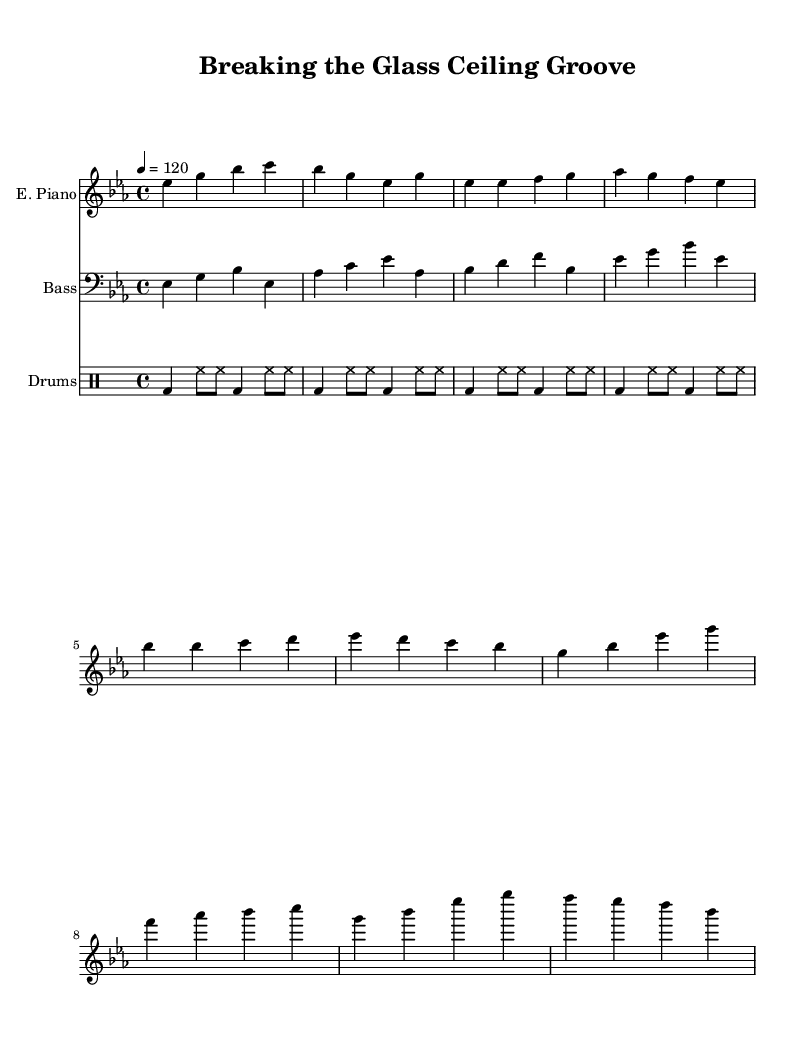What is the key signature of this music? The key signature is E flat major, which has three flats (B flat, E flat, and A flat).
Answer: E flat major What is the time signature of this music? The time signature is 4/4, which means there are four beats in a measure, and the quarter note gets one beat.
Answer: 4/4 What is the tempo marking given in the piece? The tempo marking is indicated as quarter note equals 120 beats per minute.
Answer: 120 What type of piano is indicated in the music? The music specifies an electric piano as the instrument for the melody line.
Answer: Electric Piano How many measures are in the chorus section? There are four measures in the chorus section, as seen by counting the bars shown for that part.
Answer: 4 What rhythmic pattern is primarily used in the drum section? The drum pattern features a four-on-the-floor rhythm primarily, with a bass drum on every beat and hi-hats playing in between.
Answer: Four-on-the-floor What does the "E. Piano" refer to in the score? "E. Piano" refers to the electric piano part within the score, indicating which staff it belongs to.
Answer: Electric Piano 